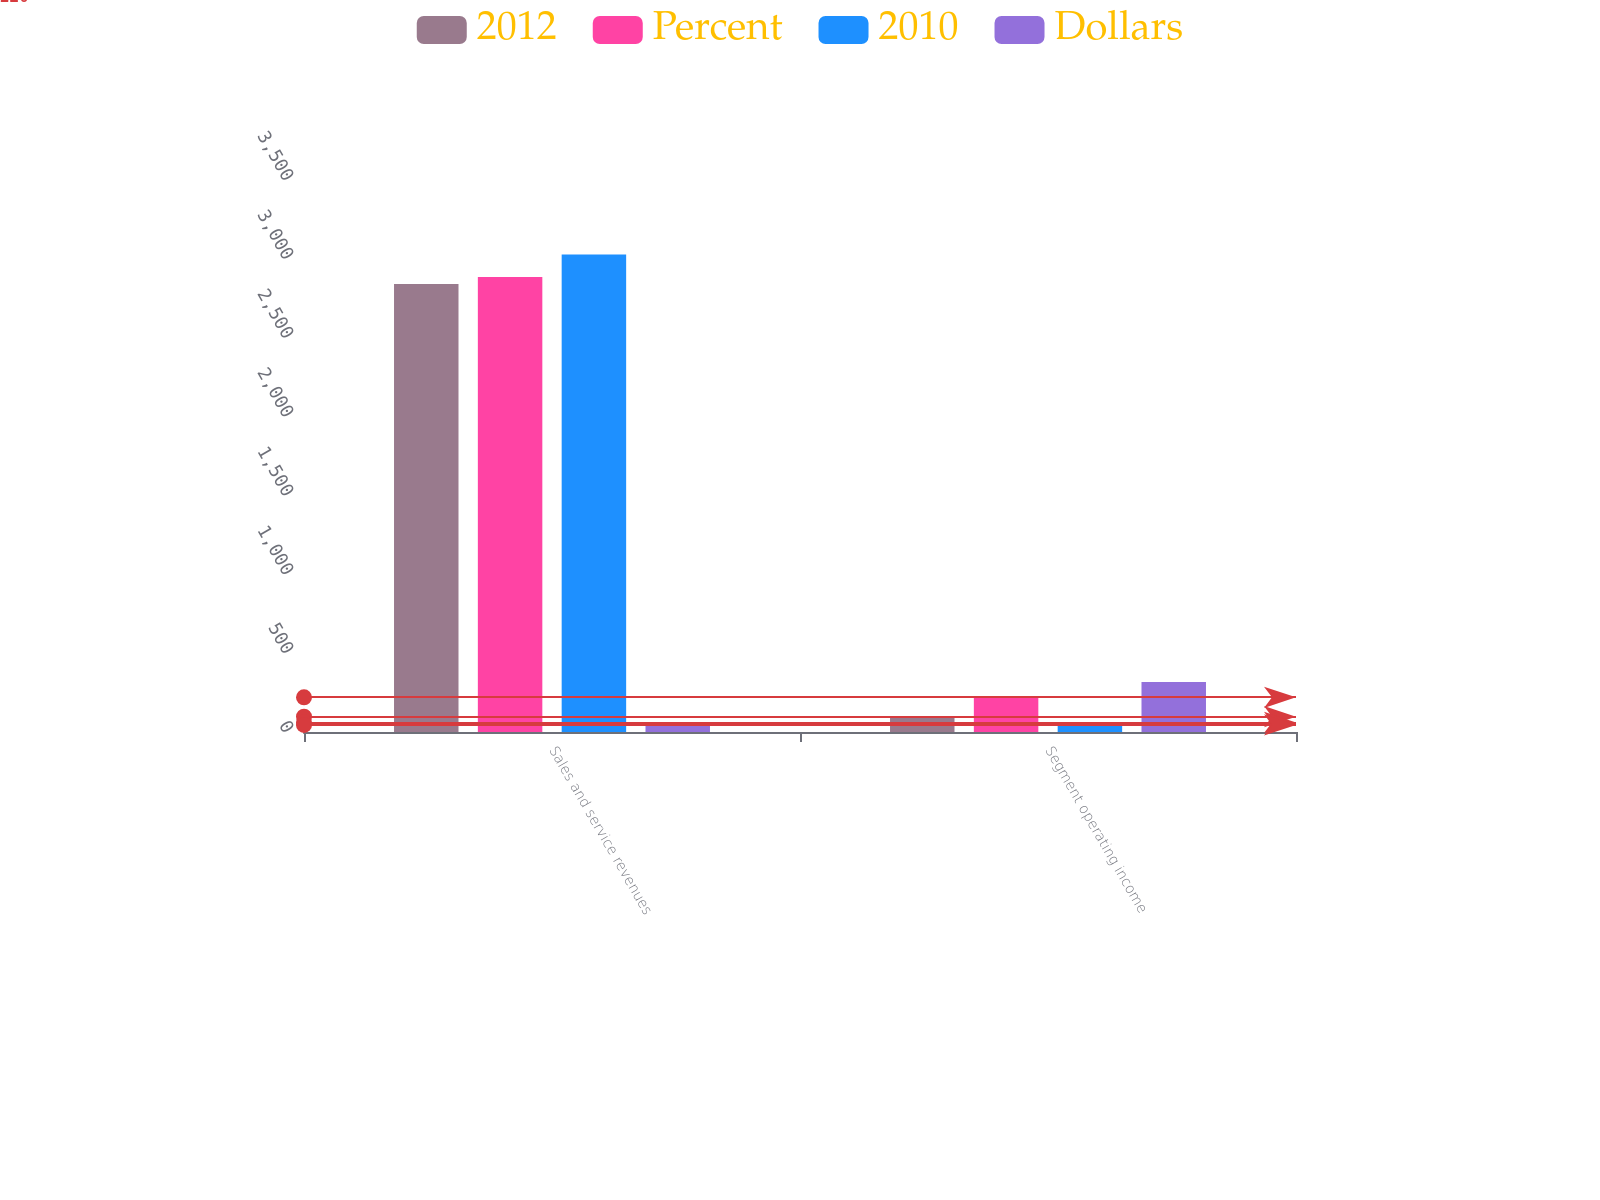Convert chart. <chart><loc_0><loc_0><loc_500><loc_500><stacked_bar_chart><ecel><fcel>Sales and service revenues<fcel>Segment operating income<nl><fcel>2012<fcel>2840<fcel>97<nl><fcel>Percent<fcel>2885<fcel>220<nl><fcel>2010<fcel>3027<fcel>61<nl><fcel>Dollars<fcel>45<fcel>317<nl></chart> 